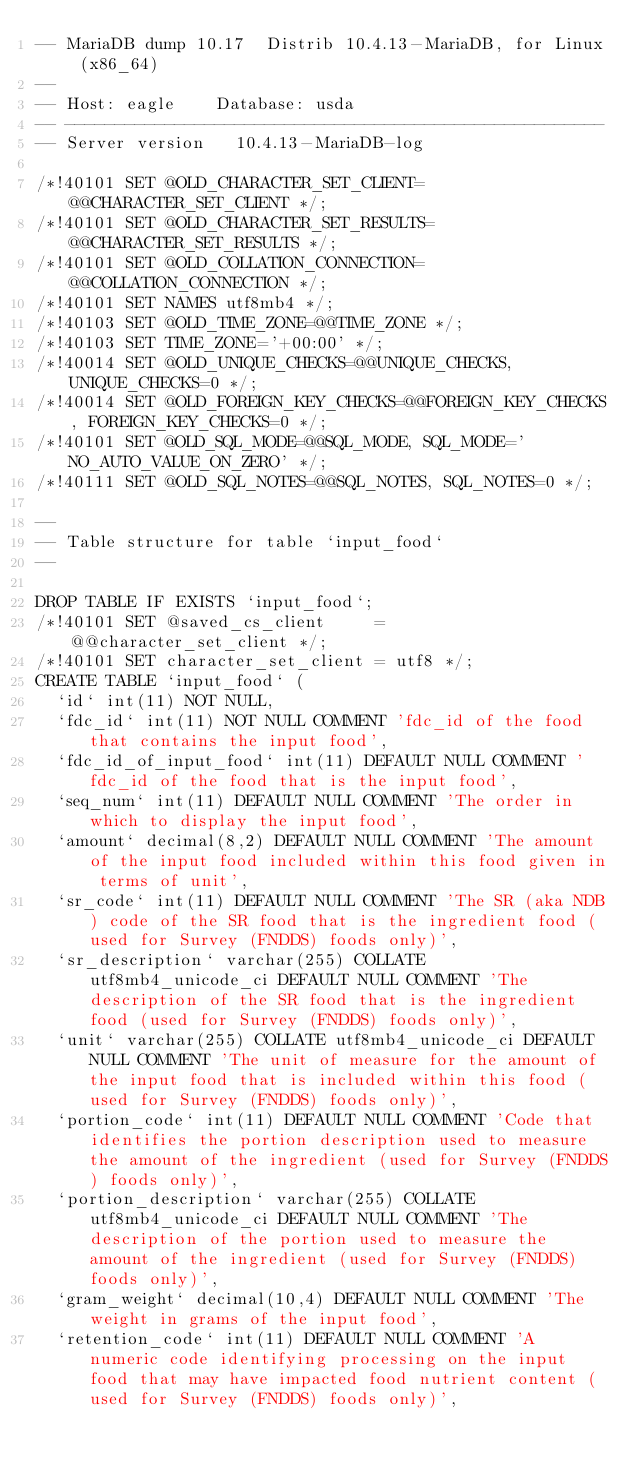Convert code to text. <code><loc_0><loc_0><loc_500><loc_500><_SQL_>-- MariaDB dump 10.17  Distrib 10.4.13-MariaDB, for Linux (x86_64)
--
-- Host: eagle    Database: usda
-- ------------------------------------------------------
-- Server version	10.4.13-MariaDB-log

/*!40101 SET @OLD_CHARACTER_SET_CLIENT=@@CHARACTER_SET_CLIENT */;
/*!40101 SET @OLD_CHARACTER_SET_RESULTS=@@CHARACTER_SET_RESULTS */;
/*!40101 SET @OLD_COLLATION_CONNECTION=@@COLLATION_CONNECTION */;
/*!40101 SET NAMES utf8mb4 */;
/*!40103 SET @OLD_TIME_ZONE=@@TIME_ZONE */;
/*!40103 SET TIME_ZONE='+00:00' */;
/*!40014 SET @OLD_UNIQUE_CHECKS=@@UNIQUE_CHECKS, UNIQUE_CHECKS=0 */;
/*!40014 SET @OLD_FOREIGN_KEY_CHECKS=@@FOREIGN_KEY_CHECKS, FOREIGN_KEY_CHECKS=0 */;
/*!40101 SET @OLD_SQL_MODE=@@SQL_MODE, SQL_MODE='NO_AUTO_VALUE_ON_ZERO' */;
/*!40111 SET @OLD_SQL_NOTES=@@SQL_NOTES, SQL_NOTES=0 */;

--
-- Table structure for table `input_food`
--

DROP TABLE IF EXISTS `input_food`;
/*!40101 SET @saved_cs_client     = @@character_set_client */;
/*!40101 SET character_set_client = utf8 */;
CREATE TABLE `input_food` (
  `id` int(11) NOT NULL,
  `fdc_id` int(11) NOT NULL COMMENT 'fdc_id of the food that contains the input food',
  `fdc_id_of_input_food` int(11) DEFAULT NULL COMMENT 'fdc_id of the food that is the input food',
  `seq_num` int(11) DEFAULT NULL COMMENT 'The order in which to display the input food',
  `amount` decimal(8,2) DEFAULT NULL COMMENT 'The amount of the input food included within this food given in terms of unit',
  `sr_code` int(11) DEFAULT NULL COMMENT 'The SR (aka NDB) code of the SR food that is the ingredient food (used for Survey (FNDDS) foods only)',
  `sr_description` varchar(255) COLLATE utf8mb4_unicode_ci DEFAULT NULL COMMENT 'The description of the SR food that is the ingredient food (used for Survey (FNDDS) foods only)',
  `unit` varchar(255) COLLATE utf8mb4_unicode_ci DEFAULT NULL COMMENT 'The unit of measure for the amount of the input food that is included within this food (used for Survey (FNDDS) foods only)',
  `portion_code` int(11) DEFAULT NULL COMMENT 'Code that identifies the portion description used to measure the amount of the ingredient (used for Survey (FNDDS) foods only)',
  `portion_description` varchar(255) COLLATE utf8mb4_unicode_ci DEFAULT NULL COMMENT 'The description of the portion used to measure the amount of the ingredient (used for Survey (FNDDS) foods only)',
  `gram_weight` decimal(10,4) DEFAULT NULL COMMENT 'The weight in grams of the input food',
  `retention_code` int(11) DEFAULT NULL COMMENT 'A numeric code identifying processing on the input food that may have impacted food nutrient content (used for Survey (FNDDS) foods only)',</code> 